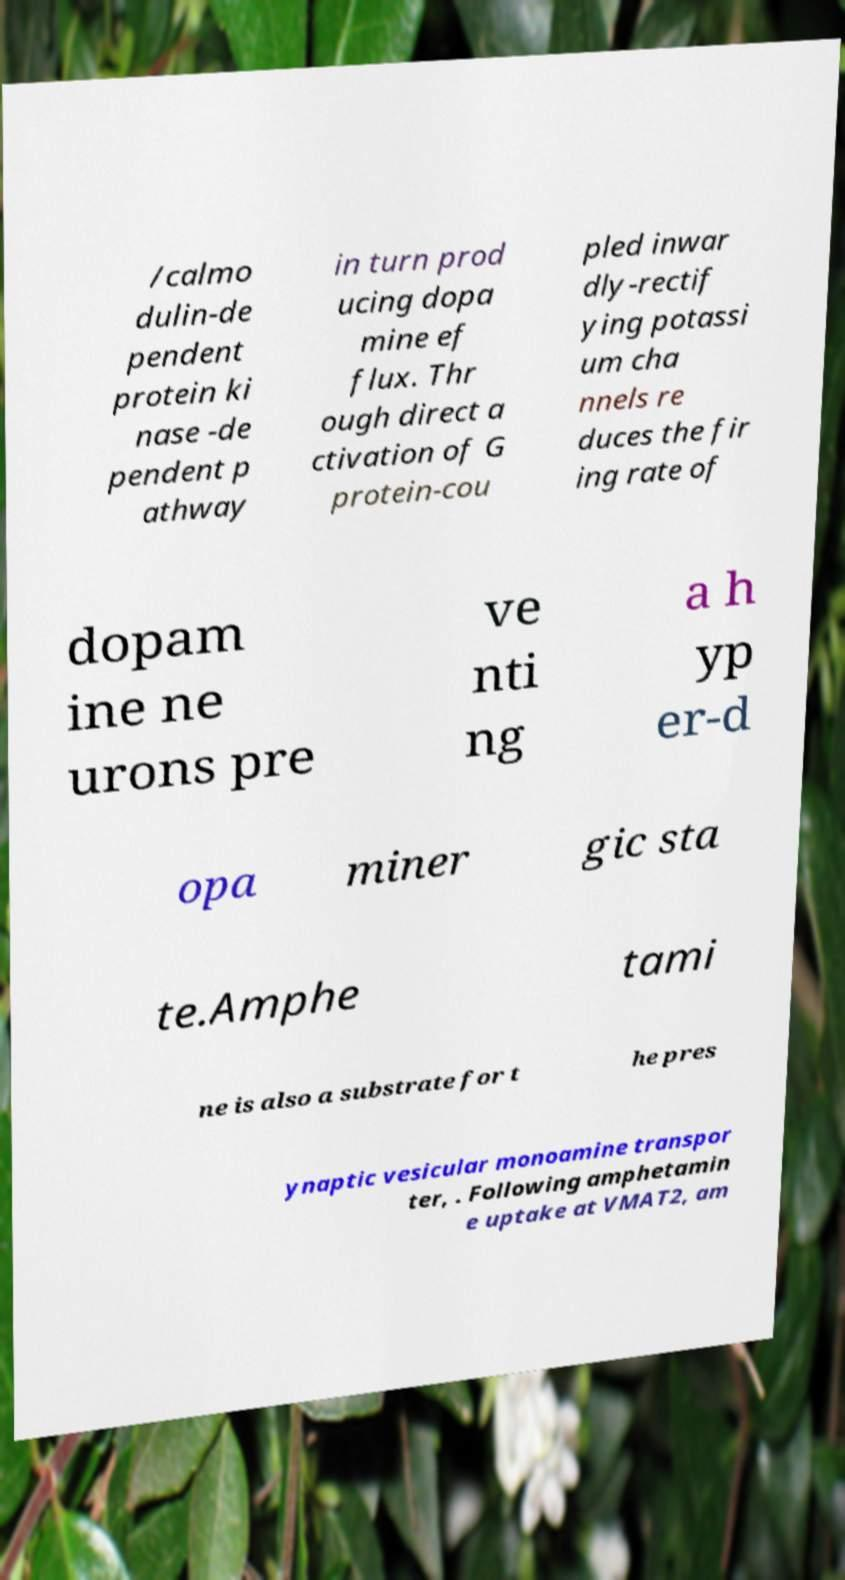Could you extract and type out the text from this image? /calmo dulin-de pendent protein ki nase -de pendent p athway in turn prod ucing dopa mine ef flux. Thr ough direct a ctivation of G protein-cou pled inwar dly-rectif ying potassi um cha nnels re duces the fir ing rate of dopam ine ne urons pre ve nti ng a h yp er-d opa miner gic sta te.Amphe tami ne is also a substrate for t he pres ynaptic vesicular monoamine transpor ter, . Following amphetamin e uptake at VMAT2, am 